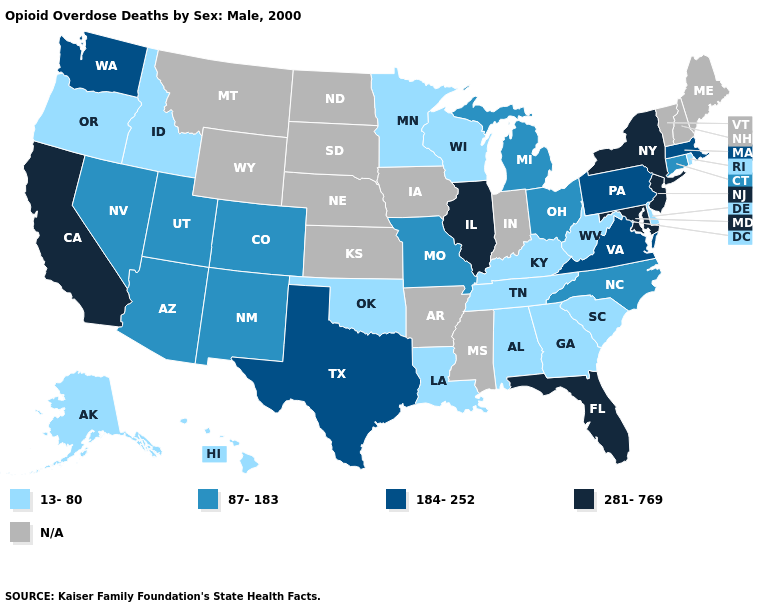What is the value of Minnesota?
Short answer required. 13-80. How many symbols are there in the legend?
Concise answer only. 5. What is the lowest value in the West?
Write a very short answer. 13-80. Among the states that border New Jersey , which have the highest value?
Keep it brief. New York. What is the highest value in the USA?
Keep it brief. 281-769. What is the value of Arizona?
Concise answer only. 87-183. Name the states that have a value in the range 13-80?
Quick response, please. Alabama, Alaska, Delaware, Georgia, Hawaii, Idaho, Kentucky, Louisiana, Minnesota, Oklahoma, Oregon, Rhode Island, South Carolina, Tennessee, West Virginia, Wisconsin. Name the states that have a value in the range 184-252?
Write a very short answer. Massachusetts, Pennsylvania, Texas, Virginia, Washington. Name the states that have a value in the range N/A?
Short answer required. Arkansas, Indiana, Iowa, Kansas, Maine, Mississippi, Montana, Nebraska, New Hampshire, North Dakota, South Dakota, Vermont, Wyoming. Does California have the highest value in the West?
Keep it brief. Yes. What is the highest value in states that border Utah?
Give a very brief answer. 87-183. What is the highest value in the West ?
Be succinct. 281-769. Does the map have missing data?
Write a very short answer. Yes. Is the legend a continuous bar?
Concise answer only. No. 